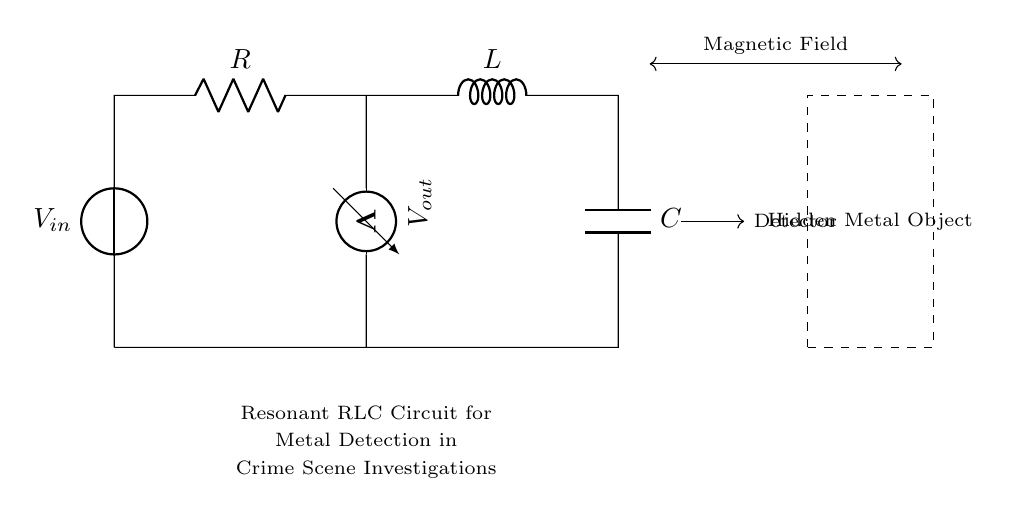What components are present in the circuit? The circuit includes a voltage source, a resistor, an inductor, and a capacitor, which are all clearly labeled in the diagram.
Answer: voltage source, resistor, inductor, capacitor What does the voltmeter measure? The voltmeter measures the voltage across the resistor in the circuit. This is indicated by the label next to the voltmeter connected at that specific point.
Answer: voltage across the resistor What is the role of the inductor in this circuit? The inductor in this circuit is used to create a magnetic field, which is essential for detecting hidden metal objects, as indicated by the description in the diagram.
Answer: create a magnetic field Why is resonance important in this circuit? Resonance in an RLC circuit allows for maximum current flow at a specific frequency, enhancing the circuit's sensitivity in detecting metal objects. This is crucial for effective metal detection in crime scene investigations.
Answer: enhances sensitivity What effect does the hidden metal object have on the magnetic field? The hidden metal object interacts with the magnetic field generated by the inductor, which can alter the current in the circuit, potentially triggering a response in the detection system.
Answer: alters the magnetic field What type of circuit is shown in the diagram? The circuit is a resonant RLC circuit, which includes resistive, inductive, and capacitive components arranged to exploit resonance for detection purposes.
Answer: resonant RLC circuit 